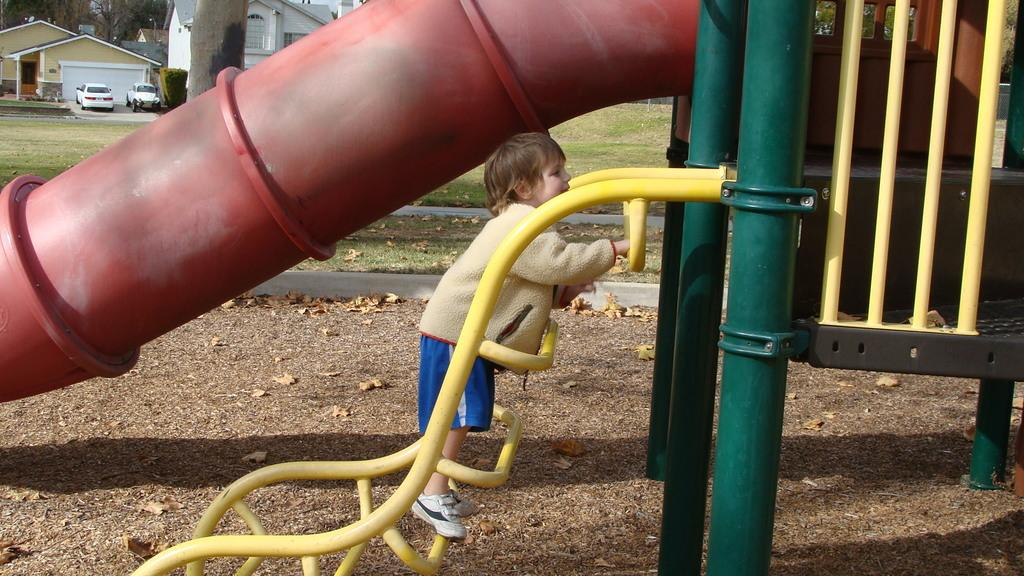What is the boy doing in the image? The boy is standing on a ladder in the image. What type of playground equipment is present in the image? There is a tube slide in the image. What can be seen in the background of the image? There are houses, trees, plants, and vehicles in the background of the image. What color is the sock on the boy's neck in the image? There is no sock or mention of a neck in the image; the boy is simply standing on a ladder? 